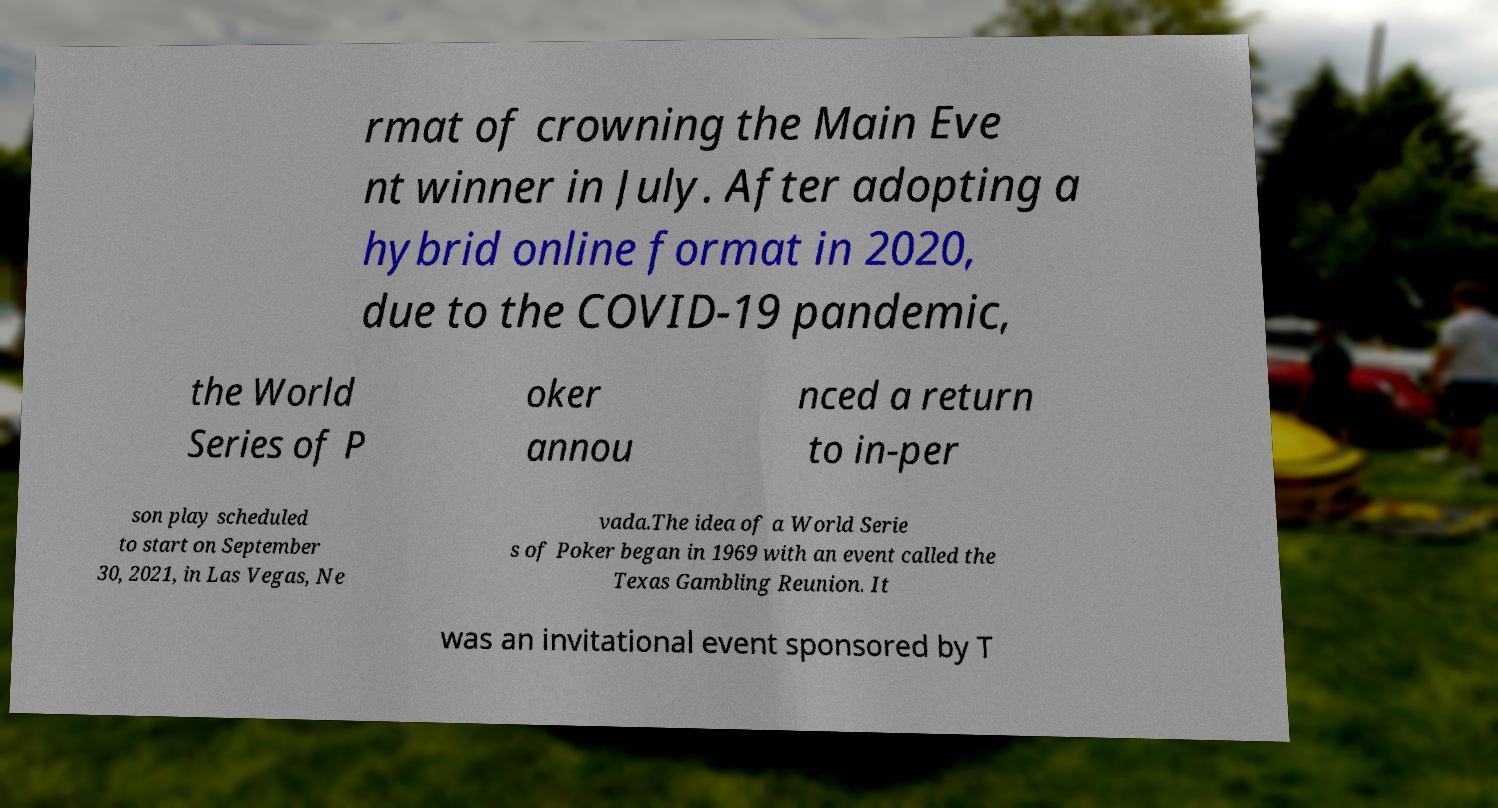Could you extract and type out the text from this image? rmat of crowning the Main Eve nt winner in July. After adopting a hybrid online format in 2020, due to the COVID-19 pandemic, the World Series of P oker annou nced a return to in-per son play scheduled to start on September 30, 2021, in Las Vegas, Ne vada.The idea of a World Serie s of Poker began in 1969 with an event called the Texas Gambling Reunion. It was an invitational event sponsored by T 